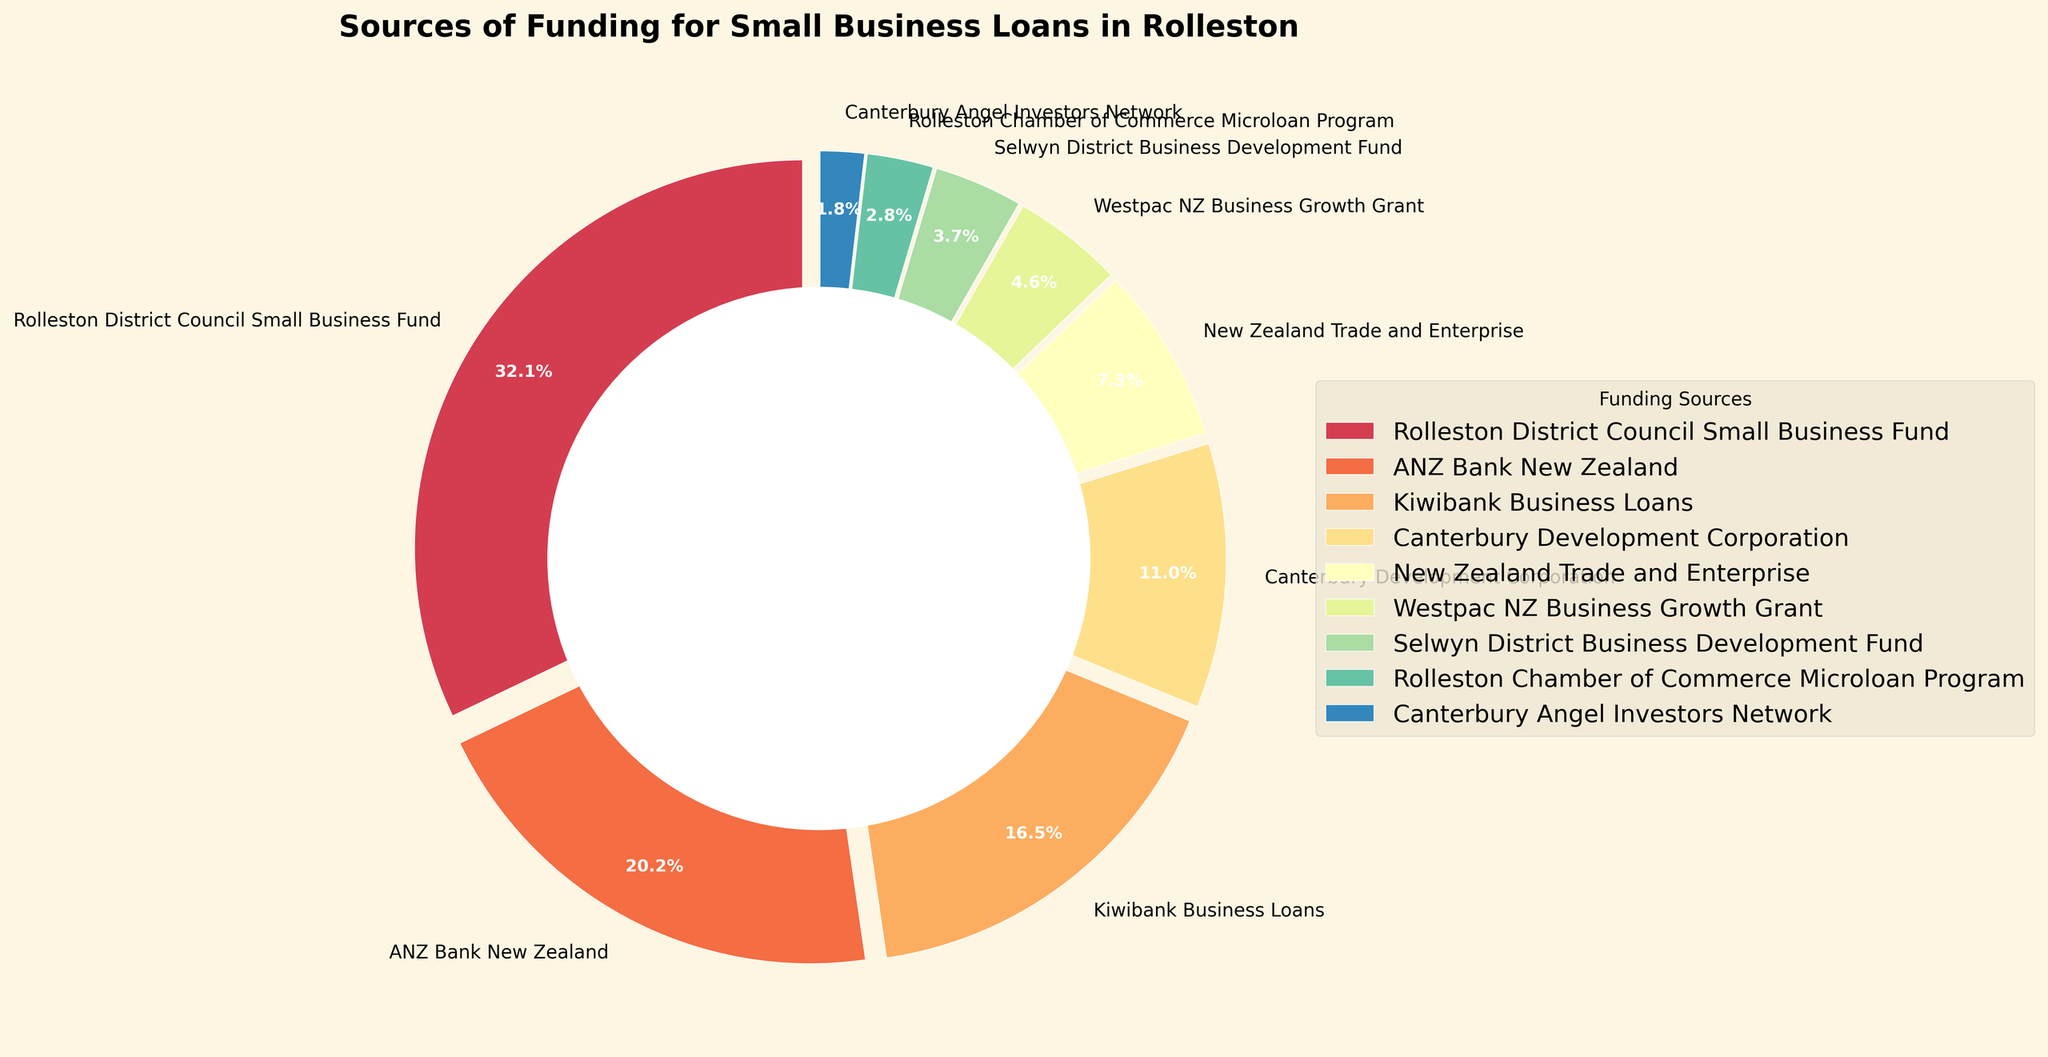What is the largest single source of funding for small business loans in Rolleston? The Rolleston District Council Small Business Fund is the largest single source, contributing 35% of the total funding. This can be seen on the chart where the largest wedge is labeled "Rolleston District Council Small Business Fund."
Answer: Rolleston District Council Small Business Fund What percentage of funding comes from banks (ANZ Bank New Zealand and Kiwibank Business Loans)? Adding the percentages of ANZ Bank New Zealand (22%) and Kiwibank Business Loans (18%) gives a total of 40% of the funding from these two sources. The chart shows these two sources labeled with their individual percentages.
Answer: 40% Which source provides less funding: Canterbury Development Corporation or New Zealand Trade and Enterprise? From the chart, we see that Canterbury Development Corporation provides 12% while New Zealand Trade and Enterprise provides 8%. We compare these figures to determine that New Zealand Trade and Enterprise provides less funding.
Answer: New Zealand Trade and Enterprise What is the total percentage of funding from Canterbury-based sources (Canterbury Development Corporation and Canterbury Angel Investors Network)? Adding the percentages from both Canterbury-based sources, which are Canterbury Development Corporation (12%) and Canterbury Angel Investors Network (2%), gives a total of 14%. The chart labels and their corresponding numerical values help in this calculation.
Answer: 14% How does the funding from Westpac NZ Business Growth Grant compare to that from Selwyn District Business Development Fund? From the chart, Westpac NZ Business Growth Grant contributes 5% while Selwyn District Business Development Fund contributes 4%. Westpac's 5% is greater than Selwyn's 4%.
Answer: Westpac NZ Business Growth Grant provides more funding If the funding from Rolleston District Council Small Business Fund were to decrease by 10%, what would the new percentage be? A 10% decrease from the Rolleston District Council Small Business Fund's current 35% would be calculated as 35% - 10% = 25%. Therefore, the new percentage would be 25%.
Answer: 25% Which funding source has the second smallest contribution and what is its percentage? Observing the list of percentages in the chart, the second smallest contributor is the Rolleston Chamber of Commerce Microloan Program at 3%. The smallest contribution is from Canterbury Angel Investors Network at 2%, making the second smallest 3%.
Answer: Rolleston Chamber of Commerce Microloan Program, 3% How much more funding does the Rolleston District Council Small Business Fund provide compared to the total funding from New Zealand Trade and Enterprise and Westpac NZ Business Growth Grant combined? The combined funding from New Zealand Trade and Enterprise (8%) and Westpac NZ Business Growth Grant (5%) is 8% + 5% = 13%. The Rolleston District Council Small Business Fund provides 35%. The difference is 35% - 13% = 22%.
Answer: 22% Which funding source is represented by the widest slice in the pie chart? The widest slice in the pie chart is labeled "Rolleston District Council Small Business Fund", representing 35% of the total funding. It visually appears as the largest wedge.
Answer: Rolleston District Council Small Business Fund 